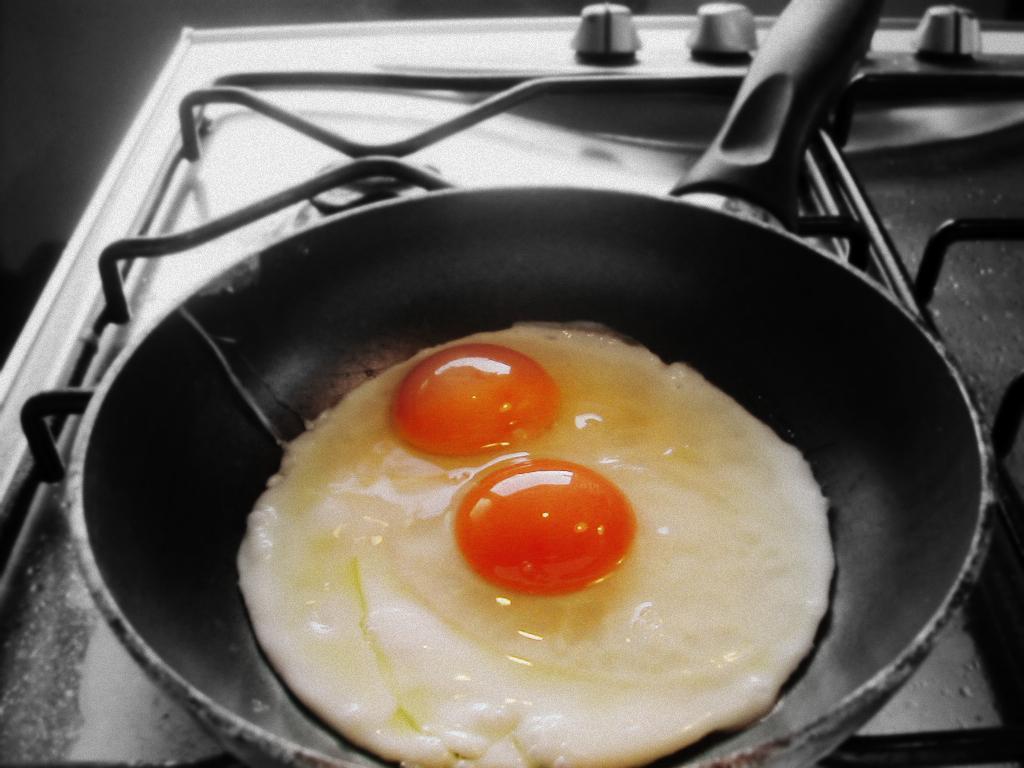Can you describe this image briefly? In this image I can see the pan with food in it. It is on the stove and I can see the black background. 